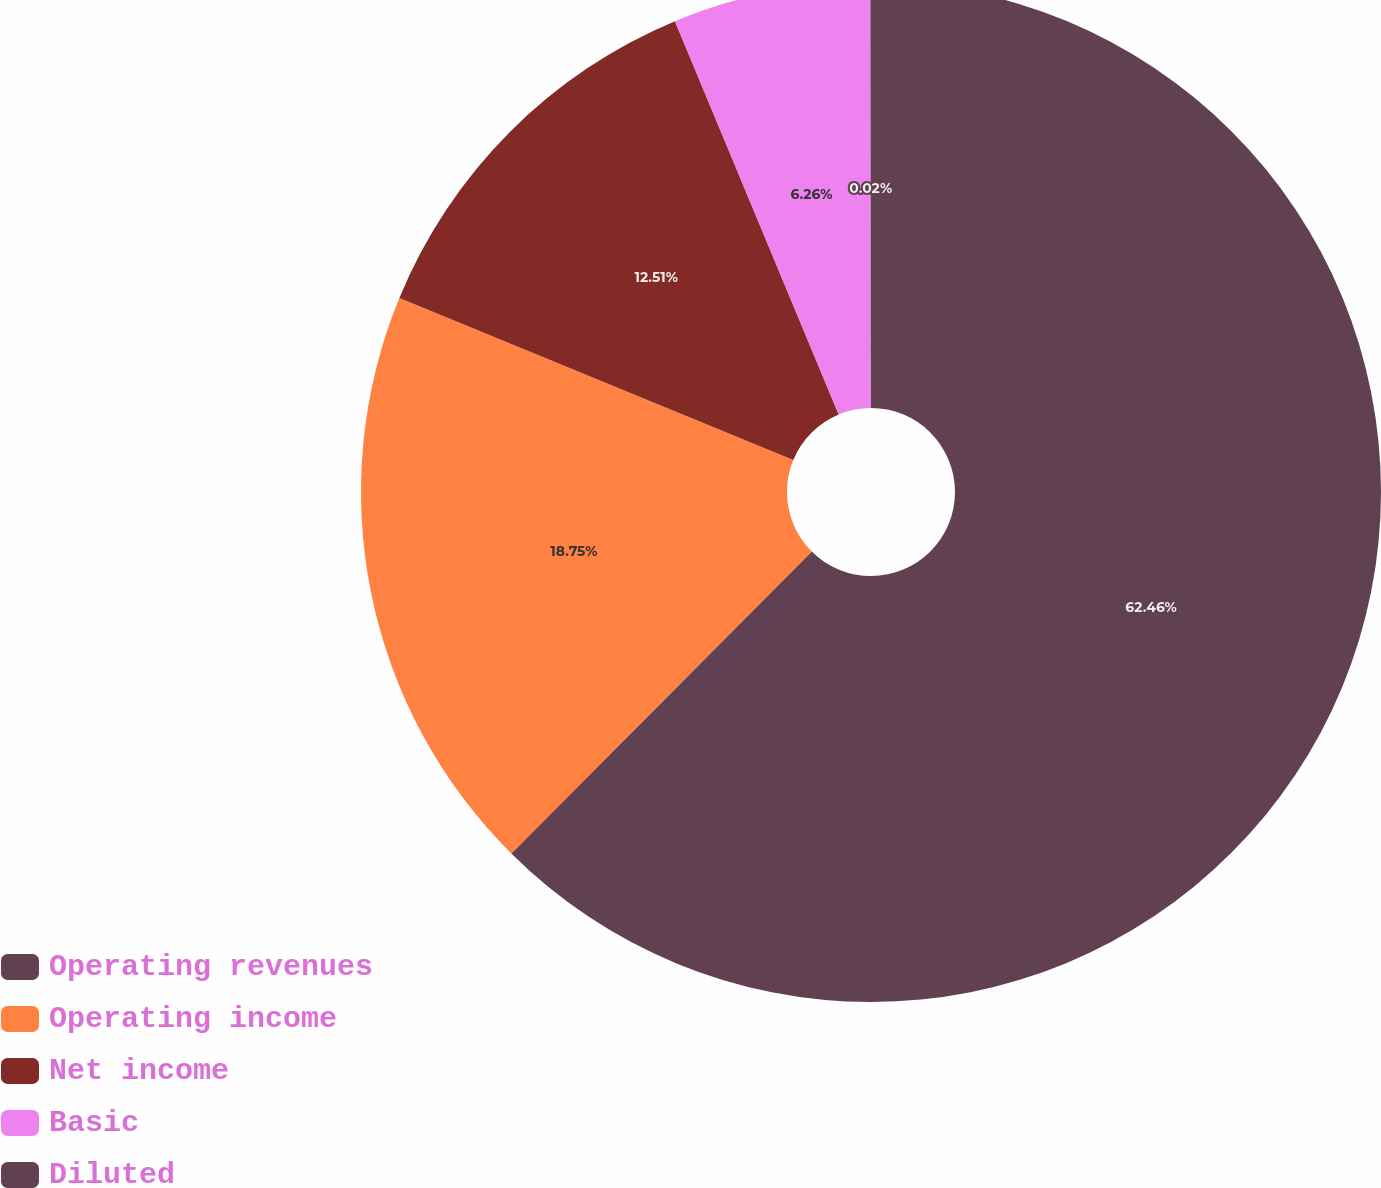Convert chart. <chart><loc_0><loc_0><loc_500><loc_500><pie_chart><fcel>Operating revenues<fcel>Operating income<fcel>Net income<fcel>Basic<fcel>Diluted<nl><fcel>62.46%<fcel>18.75%<fcel>12.51%<fcel>6.26%<fcel>0.02%<nl></chart> 